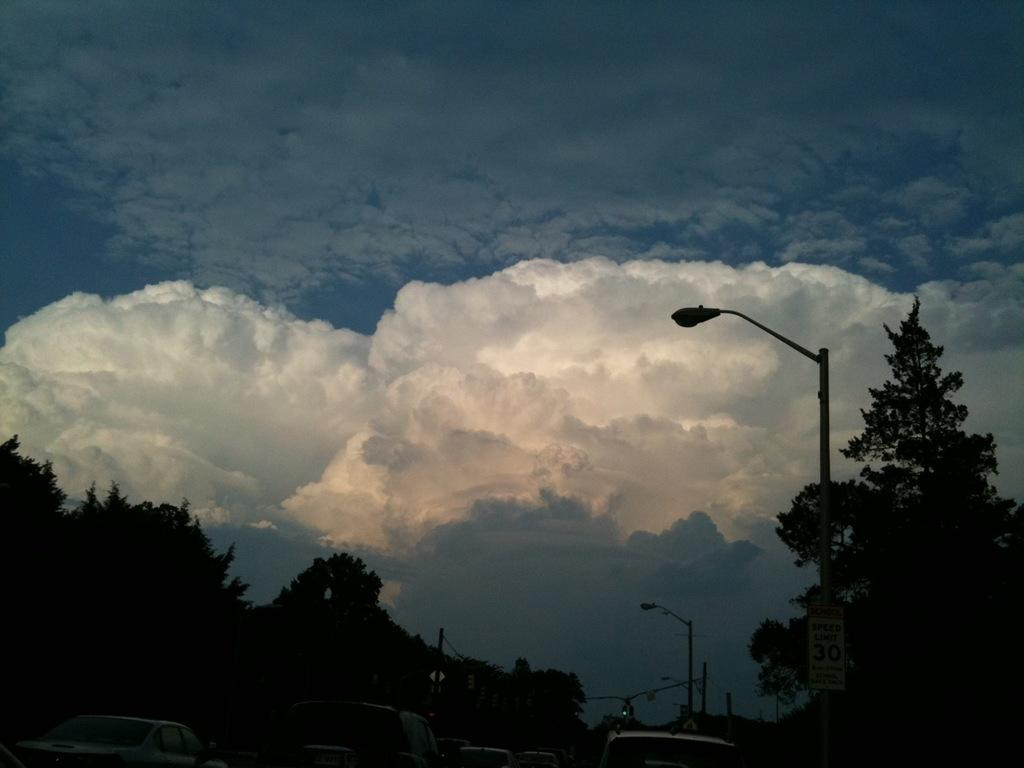What can be seen at the bottom of the image? There are many vehicles at the bottom of the image. What structures are present in the image? There are light poles in the image. What is attached to one of the light poles? There is a sign board on a light pole. What type of vegetation is visible in the image? There are trees in the image. What is visible in the background of the image? The sky with clouds is visible in the background of the image. What type of cough can be heard from the vehicles in the image? There is no sound, including coughing, present in the image. What is the desire of the trees in the image? Trees do not have desires, so this question cannot be answered. 